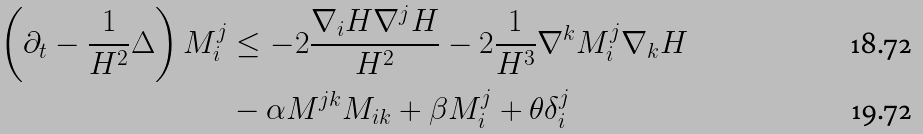<formula> <loc_0><loc_0><loc_500><loc_500>\left ( \partial _ { t } - \frac { 1 } { H ^ { 2 } } \Delta \right ) M _ { i } ^ { j } & \leq - 2 \frac { \nabla _ { i } H \nabla ^ { j } H } { H ^ { 2 } } - 2 \frac { 1 } { H ^ { 3 } } \nabla ^ { k } M _ { i } ^ { j } \nabla _ { k } H \\ & - \alpha M ^ { j k } M _ { i k } + \beta M _ { i } ^ { j } + \theta \delta _ { i } ^ { j }</formula> 